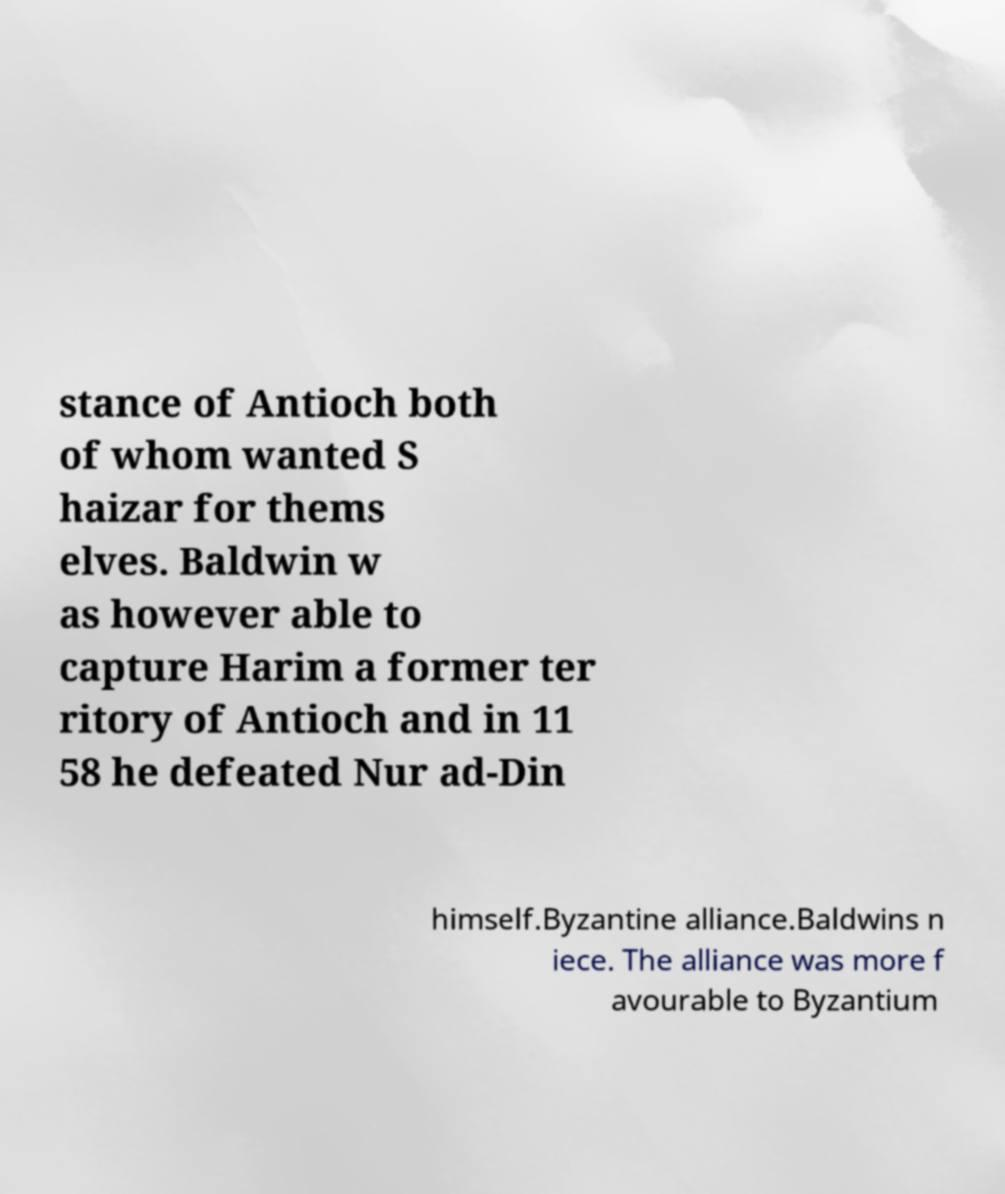For documentation purposes, I need the text within this image transcribed. Could you provide that? stance of Antioch both of whom wanted S haizar for thems elves. Baldwin w as however able to capture Harim a former ter ritory of Antioch and in 11 58 he defeated Nur ad-Din himself.Byzantine alliance.Baldwins n iece. The alliance was more f avourable to Byzantium 